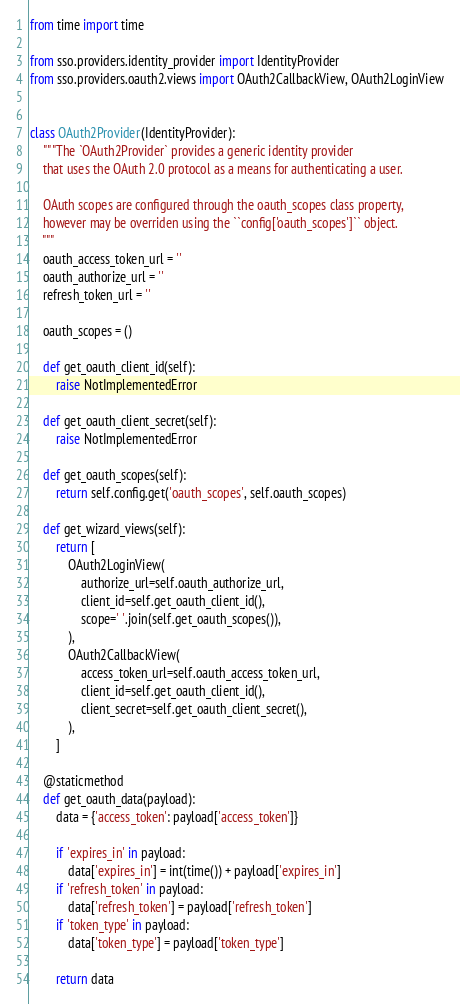<code> <loc_0><loc_0><loc_500><loc_500><_Python_>from time import time

from sso.providers.identity_provider import IdentityProvider
from sso.providers.oauth2.views import OAuth2CallbackView, OAuth2LoginView


class OAuth2Provider(IdentityProvider):
    """The `OAuth2Provider` provides a generic identity provider
    that uses the OAuth 2.0 protocol as a means for authenticating a user.

    OAuth scopes are configured through the oauth_scopes class property,
    however may be overriden using the ``config['oauth_scopes']`` object.
    """
    oauth_access_token_url = ''
    oauth_authorize_url = ''
    refresh_token_url = ''

    oauth_scopes = ()

    def get_oauth_client_id(self):
        raise NotImplementedError

    def get_oauth_client_secret(self):
        raise NotImplementedError

    def get_oauth_scopes(self):
        return self.config.get('oauth_scopes', self.oauth_scopes)

    def get_wizard_views(self):
        return [
            OAuth2LoginView(
                authorize_url=self.oauth_authorize_url,
                client_id=self.get_oauth_client_id(),
                scope=' '.join(self.get_oauth_scopes()),
            ),
            OAuth2CallbackView(
                access_token_url=self.oauth_access_token_url,
                client_id=self.get_oauth_client_id(),
                client_secret=self.get_oauth_client_secret(),
            ),
        ]

    @staticmethod
    def get_oauth_data(payload):
        data = {'access_token': payload['access_token']}

        if 'expires_in' in payload:
            data['expires_in'] = int(time()) + payload['expires_in']
        if 'refresh_token' in payload:
            data['refresh_token'] = payload['refresh_token']
        if 'token_type' in payload:
            data['token_type'] = payload['token_type']

        return data
</code> 